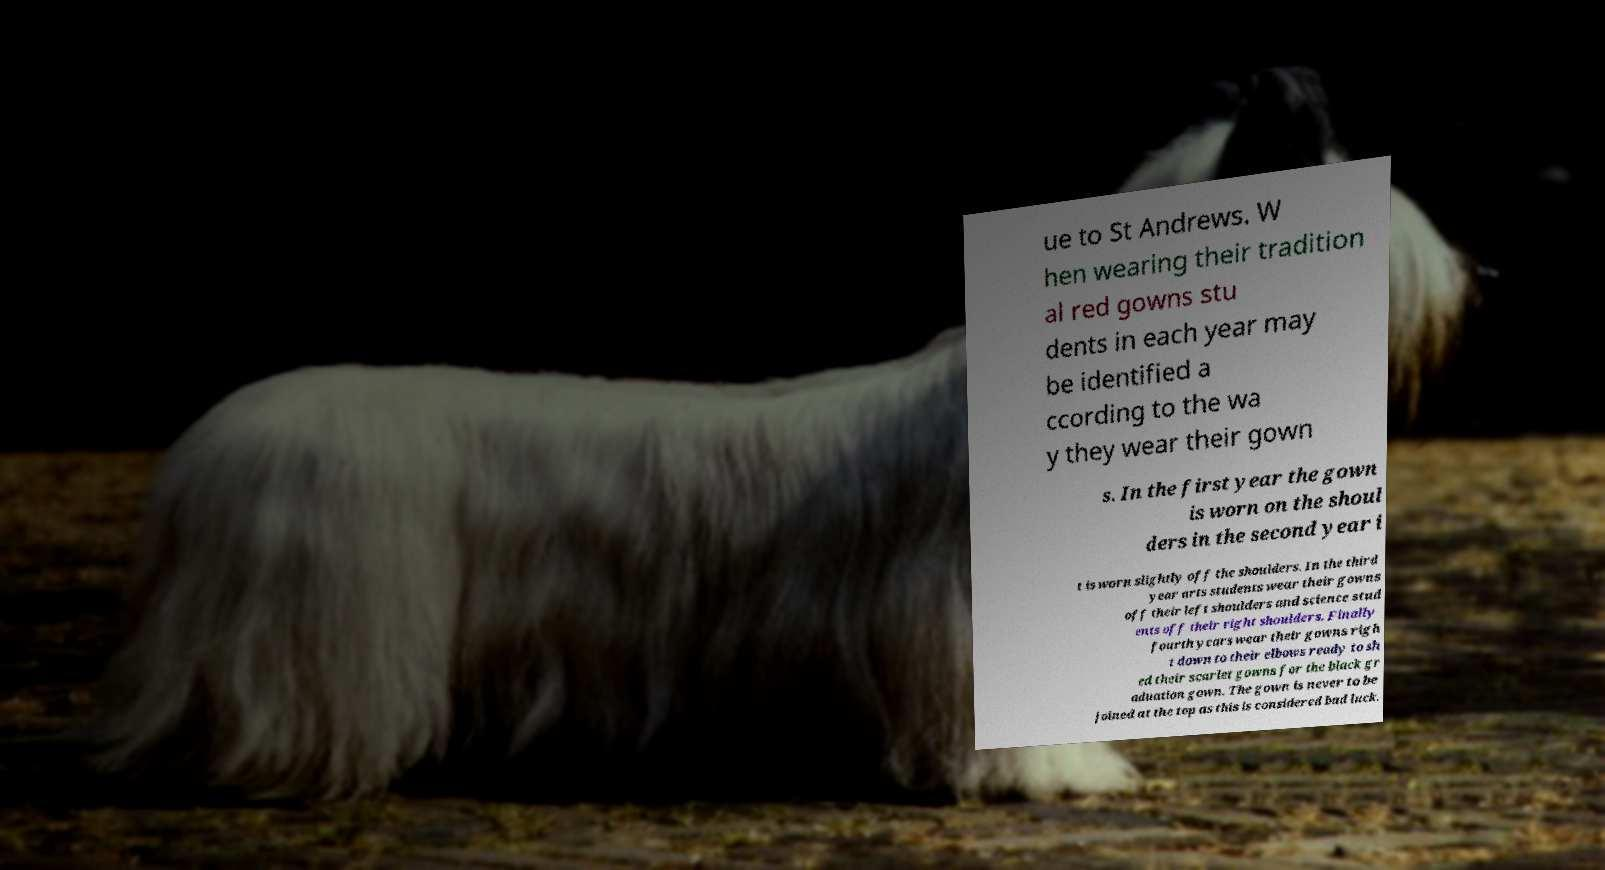Can you accurately transcribe the text from the provided image for me? ue to St Andrews. W hen wearing their tradition al red gowns stu dents in each year may be identified a ccording to the wa y they wear their gown s. In the first year the gown is worn on the shoul ders in the second year i t is worn slightly off the shoulders. In the third year arts students wear their gowns off their left shoulders and science stud ents off their right shoulders. Finally fourth years wear their gowns righ t down to their elbows ready to sh ed their scarlet gowns for the black gr aduation gown. The gown is never to be joined at the top as this is considered bad luck. 